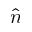<formula> <loc_0><loc_0><loc_500><loc_500>\hat { n }</formula> 